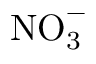Convert formula to latex. <formula><loc_0><loc_0><loc_500><loc_500>N O _ { 3 } ^ { - }</formula> 